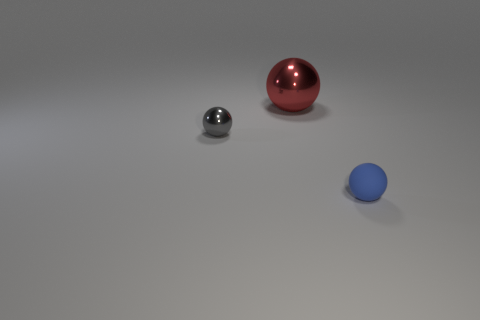Subtract all tiny rubber spheres. How many spheres are left? 2 Add 1 big gray metal spheres. How many objects exist? 4 Subtract all blue spheres. How many spheres are left? 2 Subtract 3 spheres. How many spheres are left? 0 Subtract all big balls. Subtract all large red metallic spheres. How many objects are left? 1 Add 2 red objects. How many red objects are left? 3 Add 1 small spheres. How many small spheres exist? 3 Subtract 0 yellow balls. How many objects are left? 3 Subtract all gray balls. Subtract all red cubes. How many balls are left? 2 Subtract all red cylinders. How many green balls are left? 0 